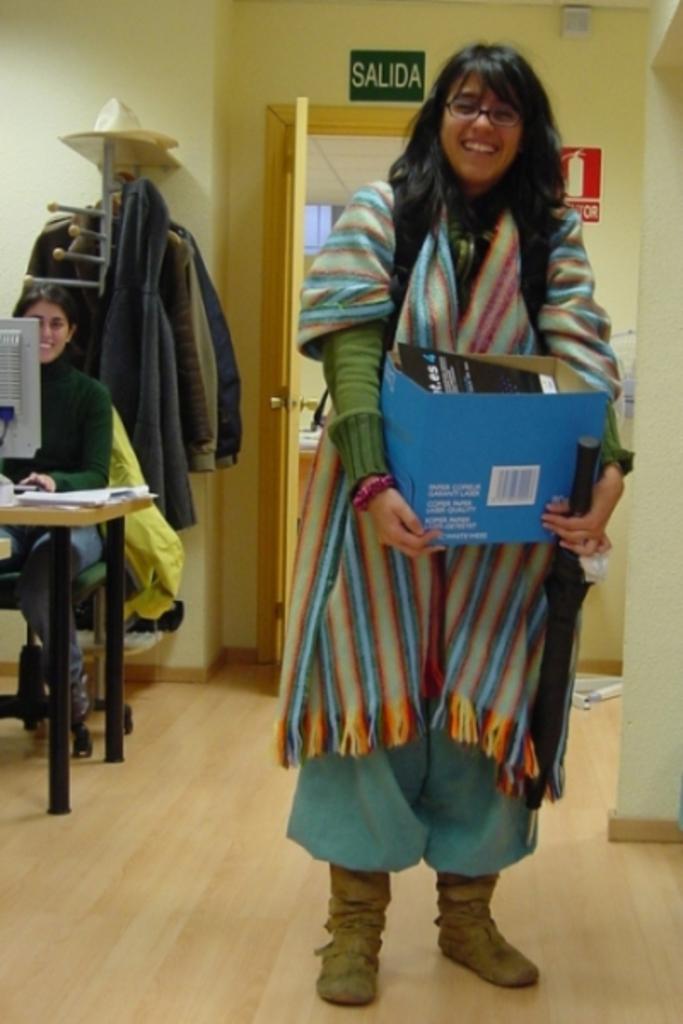Describe this image in one or two sentences. In the foreground I can see a woman is holding a box in hand is standing on the floor. In the background I can see a woman is sitting on the chair in front of a table on which I can see a PC, clothes hanger, wall, board and a door. This image is taken in a hall. 